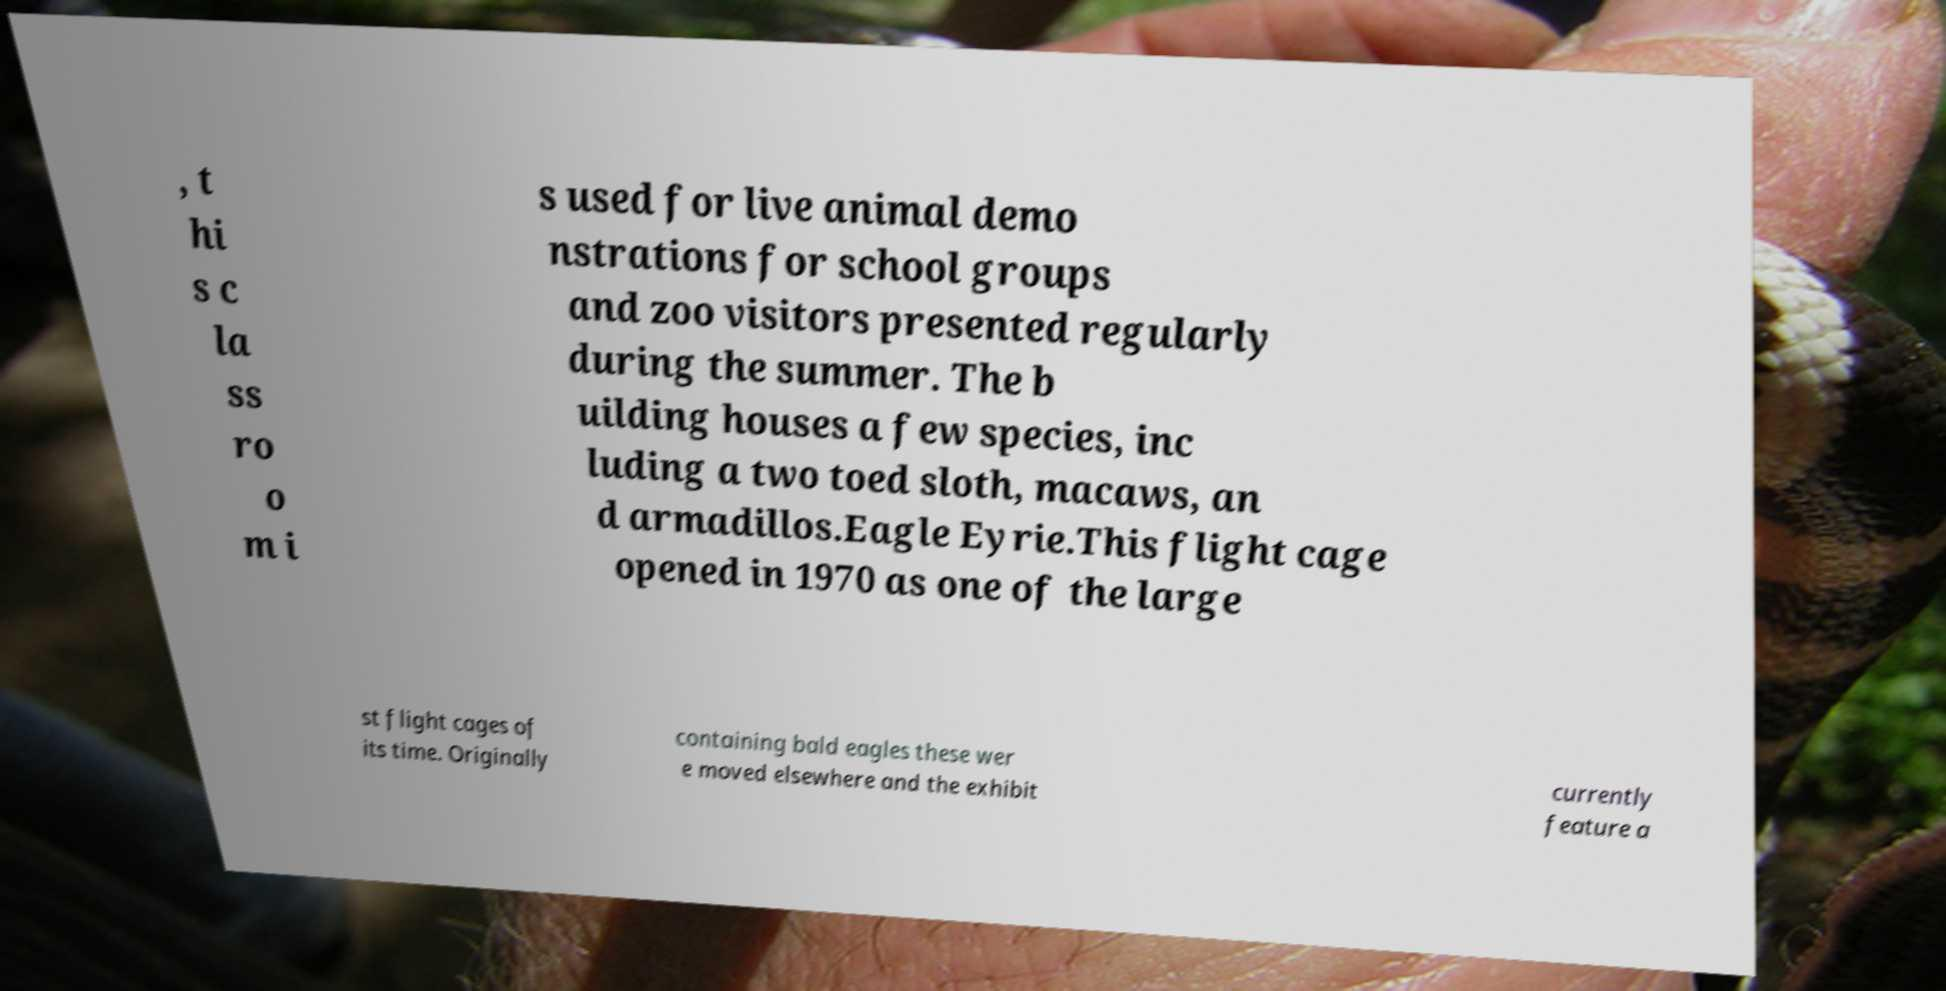Can you read and provide the text displayed in the image?This photo seems to have some interesting text. Can you extract and type it out for me? , t hi s c la ss ro o m i s used for live animal demo nstrations for school groups and zoo visitors presented regularly during the summer. The b uilding houses a few species, inc luding a two toed sloth, macaws, an d armadillos.Eagle Eyrie.This flight cage opened in 1970 as one of the large st flight cages of its time. Originally containing bald eagles these wer e moved elsewhere and the exhibit currently feature a 